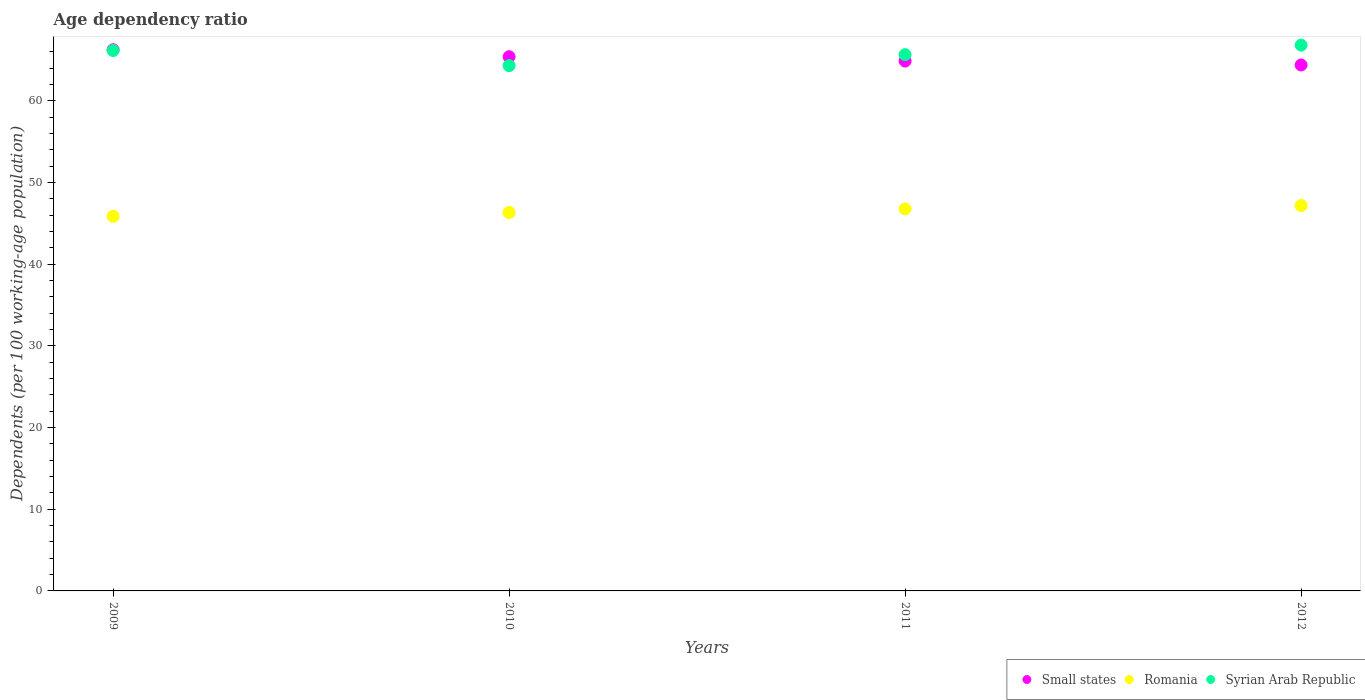How many different coloured dotlines are there?
Provide a succinct answer. 3. Is the number of dotlines equal to the number of legend labels?
Ensure brevity in your answer.  Yes. What is the age dependency ratio in in Romania in 2011?
Ensure brevity in your answer.  46.77. Across all years, what is the maximum age dependency ratio in in Small states?
Your response must be concise. 66.26. Across all years, what is the minimum age dependency ratio in in Small states?
Your response must be concise. 64.39. In which year was the age dependency ratio in in Romania minimum?
Your answer should be compact. 2009. What is the total age dependency ratio in in Small states in the graph?
Make the answer very short. 260.93. What is the difference between the age dependency ratio in in Small states in 2009 and that in 2010?
Your response must be concise. 0.85. What is the difference between the age dependency ratio in in Syrian Arab Republic in 2011 and the age dependency ratio in in Small states in 2012?
Your answer should be compact. 1.26. What is the average age dependency ratio in in Small states per year?
Make the answer very short. 65.23. In the year 2009, what is the difference between the age dependency ratio in in Small states and age dependency ratio in in Romania?
Provide a short and direct response. 20.39. What is the ratio of the age dependency ratio in in Syrian Arab Republic in 2010 to that in 2012?
Offer a very short reply. 0.96. Is the age dependency ratio in in Small states in 2010 less than that in 2012?
Your answer should be compact. No. Is the difference between the age dependency ratio in in Small states in 2011 and 2012 greater than the difference between the age dependency ratio in in Romania in 2011 and 2012?
Give a very brief answer. Yes. What is the difference between the highest and the second highest age dependency ratio in in Romania?
Make the answer very short. 0.41. What is the difference between the highest and the lowest age dependency ratio in in Small states?
Provide a short and direct response. 1.86. Is the sum of the age dependency ratio in in Small states in 2010 and 2011 greater than the maximum age dependency ratio in in Romania across all years?
Make the answer very short. Yes. Does the age dependency ratio in in Syrian Arab Republic monotonically increase over the years?
Your answer should be compact. No. Is the age dependency ratio in in Romania strictly greater than the age dependency ratio in in Small states over the years?
Your response must be concise. No. How many dotlines are there?
Provide a short and direct response. 3. How many years are there in the graph?
Offer a terse response. 4. What is the difference between two consecutive major ticks on the Y-axis?
Give a very brief answer. 10. Does the graph contain any zero values?
Make the answer very short. No. Where does the legend appear in the graph?
Your response must be concise. Bottom right. How many legend labels are there?
Make the answer very short. 3. What is the title of the graph?
Keep it short and to the point. Age dependency ratio. What is the label or title of the X-axis?
Offer a terse response. Years. What is the label or title of the Y-axis?
Ensure brevity in your answer.  Dependents (per 100 working-age population). What is the Dependents (per 100 working-age population) in Small states in 2009?
Offer a very short reply. 66.26. What is the Dependents (per 100 working-age population) in Romania in 2009?
Ensure brevity in your answer.  45.87. What is the Dependents (per 100 working-age population) of Syrian Arab Republic in 2009?
Your answer should be very brief. 66.16. What is the Dependents (per 100 working-age population) of Small states in 2010?
Your answer should be very brief. 65.41. What is the Dependents (per 100 working-age population) of Romania in 2010?
Offer a terse response. 46.33. What is the Dependents (per 100 working-age population) in Syrian Arab Republic in 2010?
Your answer should be very brief. 64.31. What is the Dependents (per 100 working-age population) in Small states in 2011?
Offer a terse response. 64.87. What is the Dependents (per 100 working-age population) in Romania in 2011?
Keep it short and to the point. 46.77. What is the Dependents (per 100 working-age population) in Syrian Arab Republic in 2011?
Ensure brevity in your answer.  65.66. What is the Dependents (per 100 working-age population) of Small states in 2012?
Provide a short and direct response. 64.39. What is the Dependents (per 100 working-age population) of Romania in 2012?
Offer a very short reply. 47.19. What is the Dependents (per 100 working-age population) in Syrian Arab Republic in 2012?
Offer a very short reply. 66.82. Across all years, what is the maximum Dependents (per 100 working-age population) in Small states?
Keep it short and to the point. 66.26. Across all years, what is the maximum Dependents (per 100 working-age population) in Romania?
Make the answer very short. 47.19. Across all years, what is the maximum Dependents (per 100 working-age population) in Syrian Arab Republic?
Ensure brevity in your answer.  66.82. Across all years, what is the minimum Dependents (per 100 working-age population) in Small states?
Make the answer very short. 64.39. Across all years, what is the minimum Dependents (per 100 working-age population) in Romania?
Make the answer very short. 45.87. Across all years, what is the minimum Dependents (per 100 working-age population) of Syrian Arab Republic?
Provide a succinct answer. 64.31. What is the total Dependents (per 100 working-age population) in Small states in the graph?
Your answer should be compact. 260.93. What is the total Dependents (per 100 working-age population) of Romania in the graph?
Provide a short and direct response. 186.16. What is the total Dependents (per 100 working-age population) of Syrian Arab Republic in the graph?
Offer a terse response. 262.96. What is the difference between the Dependents (per 100 working-age population) in Small states in 2009 and that in 2010?
Offer a terse response. 0.85. What is the difference between the Dependents (per 100 working-age population) of Romania in 2009 and that in 2010?
Offer a terse response. -0.47. What is the difference between the Dependents (per 100 working-age population) of Syrian Arab Republic in 2009 and that in 2010?
Your answer should be very brief. 1.85. What is the difference between the Dependents (per 100 working-age population) of Small states in 2009 and that in 2011?
Give a very brief answer. 1.39. What is the difference between the Dependents (per 100 working-age population) of Romania in 2009 and that in 2011?
Your response must be concise. -0.91. What is the difference between the Dependents (per 100 working-age population) in Syrian Arab Republic in 2009 and that in 2011?
Offer a very short reply. 0.51. What is the difference between the Dependents (per 100 working-age population) of Small states in 2009 and that in 2012?
Provide a succinct answer. 1.86. What is the difference between the Dependents (per 100 working-age population) of Romania in 2009 and that in 2012?
Offer a terse response. -1.32. What is the difference between the Dependents (per 100 working-age population) of Syrian Arab Republic in 2009 and that in 2012?
Make the answer very short. -0.66. What is the difference between the Dependents (per 100 working-age population) of Small states in 2010 and that in 2011?
Keep it short and to the point. 0.53. What is the difference between the Dependents (per 100 working-age population) of Romania in 2010 and that in 2011?
Your answer should be very brief. -0.44. What is the difference between the Dependents (per 100 working-age population) in Syrian Arab Republic in 2010 and that in 2011?
Keep it short and to the point. -1.34. What is the difference between the Dependents (per 100 working-age population) in Small states in 2010 and that in 2012?
Keep it short and to the point. 1.01. What is the difference between the Dependents (per 100 working-age population) in Romania in 2010 and that in 2012?
Make the answer very short. -0.85. What is the difference between the Dependents (per 100 working-age population) of Syrian Arab Republic in 2010 and that in 2012?
Provide a short and direct response. -2.51. What is the difference between the Dependents (per 100 working-age population) in Small states in 2011 and that in 2012?
Provide a short and direct response. 0.48. What is the difference between the Dependents (per 100 working-age population) of Romania in 2011 and that in 2012?
Offer a terse response. -0.41. What is the difference between the Dependents (per 100 working-age population) in Syrian Arab Republic in 2011 and that in 2012?
Keep it short and to the point. -1.17. What is the difference between the Dependents (per 100 working-age population) of Small states in 2009 and the Dependents (per 100 working-age population) of Romania in 2010?
Ensure brevity in your answer.  19.92. What is the difference between the Dependents (per 100 working-age population) of Small states in 2009 and the Dependents (per 100 working-age population) of Syrian Arab Republic in 2010?
Your response must be concise. 1.94. What is the difference between the Dependents (per 100 working-age population) in Romania in 2009 and the Dependents (per 100 working-age population) in Syrian Arab Republic in 2010?
Make the answer very short. -18.45. What is the difference between the Dependents (per 100 working-age population) in Small states in 2009 and the Dependents (per 100 working-age population) in Romania in 2011?
Keep it short and to the point. 19.48. What is the difference between the Dependents (per 100 working-age population) of Small states in 2009 and the Dependents (per 100 working-age population) of Syrian Arab Republic in 2011?
Your response must be concise. 0.6. What is the difference between the Dependents (per 100 working-age population) in Romania in 2009 and the Dependents (per 100 working-age population) in Syrian Arab Republic in 2011?
Ensure brevity in your answer.  -19.79. What is the difference between the Dependents (per 100 working-age population) of Small states in 2009 and the Dependents (per 100 working-age population) of Romania in 2012?
Provide a short and direct response. 19.07. What is the difference between the Dependents (per 100 working-age population) of Small states in 2009 and the Dependents (per 100 working-age population) of Syrian Arab Republic in 2012?
Make the answer very short. -0.57. What is the difference between the Dependents (per 100 working-age population) in Romania in 2009 and the Dependents (per 100 working-age population) in Syrian Arab Republic in 2012?
Your answer should be compact. -20.96. What is the difference between the Dependents (per 100 working-age population) of Small states in 2010 and the Dependents (per 100 working-age population) of Romania in 2011?
Give a very brief answer. 18.63. What is the difference between the Dependents (per 100 working-age population) of Small states in 2010 and the Dependents (per 100 working-age population) of Syrian Arab Republic in 2011?
Your response must be concise. -0.25. What is the difference between the Dependents (per 100 working-age population) in Romania in 2010 and the Dependents (per 100 working-age population) in Syrian Arab Republic in 2011?
Keep it short and to the point. -19.32. What is the difference between the Dependents (per 100 working-age population) in Small states in 2010 and the Dependents (per 100 working-age population) in Romania in 2012?
Your response must be concise. 18.22. What is the difference between the Dependents (per 100 working-age population) of Small states in 2010 and the Dependents (per 100 working-age population) of Syrian Arab Republic in 2012?
Your answer should be very brief. -1.42. What is the difference between the Dependents (per 100 working-age population) of Romania in 2010 and the Dependents (per 100 working-age population) of Syrian Arab Republic in 2012?
Give a very brief answer. -20.49. What is the difference between the Dependents (per 100 working-age population) in Small states in 2011 and the Dependents (per 100 working-age population) in Romania in 2012?
Give a very brief answer. 17.69. What is the difference between the Dependents (per 100 working-age population) of Small states in 2011 and the Dependents (per 100 working-age population) of Syrian Arab Republic in 2012?
Your response must be concise. -1.95. What is the difference between the Dependents (per 100 working-age population) of Romania in 2011 and the Dependents (per 100 working-age population) of Syrian Arab Republic in 2012?
Make the answer very short. -20.05. What is the average Dependents (per 100 working-age population) of Small states per year?
Your answer should be very brief. 65.23. What is the average Dependents (per 100 working-age population) in Romania per year?
Provide a short and direct response. 46.54. What is the average Dependents (per 100 working-age population) in Syrian Arab Republic per year?
Provide a succinct answer. 65.74. In the year 2009, what is the difference between the Dependents (per 100 working-age population) of Small states and Dependents (per 100 working-age population) of Romania?
Your response must be concise. 20.39. In the year 2009, what is the difference between the Dependents (per 100 working-age population) of Small states and Dependents (per 100 working-age population) of Syrian Arab Republic?
Your response must be concise. 0.09. In the year 2009, what is the difference between the Dependents (per 100 working-age population) in Romania and Dependents (per 100 working-age population) in Syrian Arab Republic?
Ensure brevity in your answer.  -20.3. In the year 2010, what is the difference between the Dependents (per 100 working-age population) of Small states and Dependents (per 100 working-age population) of Romania?
Your response must be concise. 19.07. In the year 2010, what is the difference between the Dependents (per 100 working-age population) in Small states and Dependents (per 100 working-age population) in Syrian Arab Republic?
Your response must be concise. 1.09. In the year 2010, what is the difference between the Dependents (per 100 working-age population) of Romania and Dependents (per 100 working-age population) of Syrian Arab Republic?
Make the answer very short. -17.98. In the year 2011, what is the difference between the Dependents (per 100 working-age population) in Small states and Dependents (per 100 working-age population) in Romania?
Provide a short and direct response. 18.1. In the year 2011, what is the difference between the Dependents (per 100 working-age population) of Small states and Dependents (per 100 working-age population) of Syrian Arab Republic?
Keep it short and to the point. -0.78. In the year 2011, what is the difference between the Dependents (per 100 working-age population) in Romania and Dependents (per 100 working-age population) in Syrian Arab Republic?
Your response must be concise. -18.88. In the year 2012, what is the difference between the Dependents (per 100 working-age population) in Small states and Dependents (per 100 working-age population) in Romania?
Keep it short and to the point. 17.21. In the year 2012, what is the difference between the Dependents (per 100 working-age population) in Small states and Dependents (per 100 working-age population) in Syrian Arab Republic?
Provide a succinct answer. -2.43. In the year 2012, what is the difference between the Dependents (per 100 working-age population) of Romania and Dependents (per 100 working-age population) of Syrian Arab Republic?
Keep it short and to the point. -19.64. What is the ratio of the Dependents (per 100 working-age population) of Syrian Arab Republic in 2009 to that in 2010?
Keep it short and to the point. 1.03. What is the ratio of the Dependents (per 100 working-age population) of Small states in 2009 to that in 2011?
Provide a short and direct response. 1.02. What is the ratio of the Dependents (per 100 working-age population) in Romania in 2009 to that in 2011?
Ensure brevity in your answer.  0.98. What is the ratio of the Dependents (per 100 working-age population) in Syrian Arab Republic in 2009 to that in 2011?
Your answer should be compact. 1.01. What is the ratio of the Dependents (per 100 working-age population) in Small states in 2010 to that in 2011?
Ensure brevity in your answer.  1.01. What is the ratio of the Dependents (per 100 working-age population) in Romania in 2010 to that in 2011?
Your response must be concise. 0.99. What is the ratio of the Dependents (per 100 working-age population) of Syrian Arab Republic in 2010 to that in 2011?
Keep it short and to the point. 0.98. What is the ratio of the Dependents (per 100 working-age population) in Small states in 2010 to that in 2012?
Your answer should be compact. 1.02. What is the ratio of the Dependents (per 100 working-age population) in Syrian Arab Republic in 2010 to that in 2012?
Make the answer very short. 0.96. What is the ratio of the Dependents (per 100 working-age population) in Small states in 2011 to that in 2012?
Offer a very short reply. 1.01. What is the ratio of the Dependents (per 100 working-age population) of Syrian Arab Republic in 2011 to that in 2012?
Your answer should be very brief. 0.98. What is the difference between the highest and the second highest Dependents (per 100 working-age population) of Small states?
Keep it short and to the point. 0.85. What is the difference between the highest and the second highest Dependents (per 100 working-age population) of Romania?
Your answer should be compact. 0.41. What is the difference between the highest and the second highest Dependents (per 100 working-age population) of Syrian Arab Republic?
Your response must be concise. 0.66. What is the difference between the highest and the lowest Dependents (per 100 working-age population) of Small states?
Provide a short and direct response. 1.86. What is the difference between the highest and the lowest Dependents (per 100 working-age population) in Romania?
Your response must be concise. 1.32. What is the difference between the highest and the lowest Dependents (per 100 working-age population) of Syrian Arab Republic?
Ensure brevity in your answer.  2.51. 